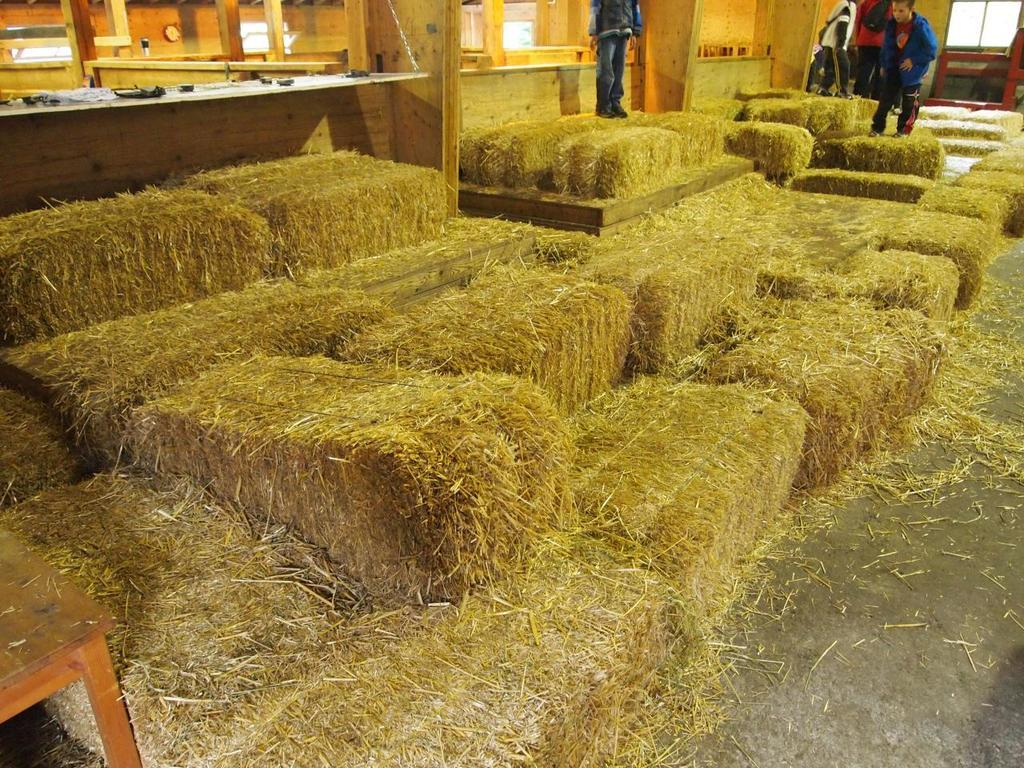What can be seen on the top of the image? There are dried grass bundles and people wearing jackets on the top of the image. What is located at the bottom left of the image? There is a table at the bottom left of the image. How does the knowledge of the people wearing jackets change in the cellar? There is no mention of a cellar or any knowledge-related changes in the image. 